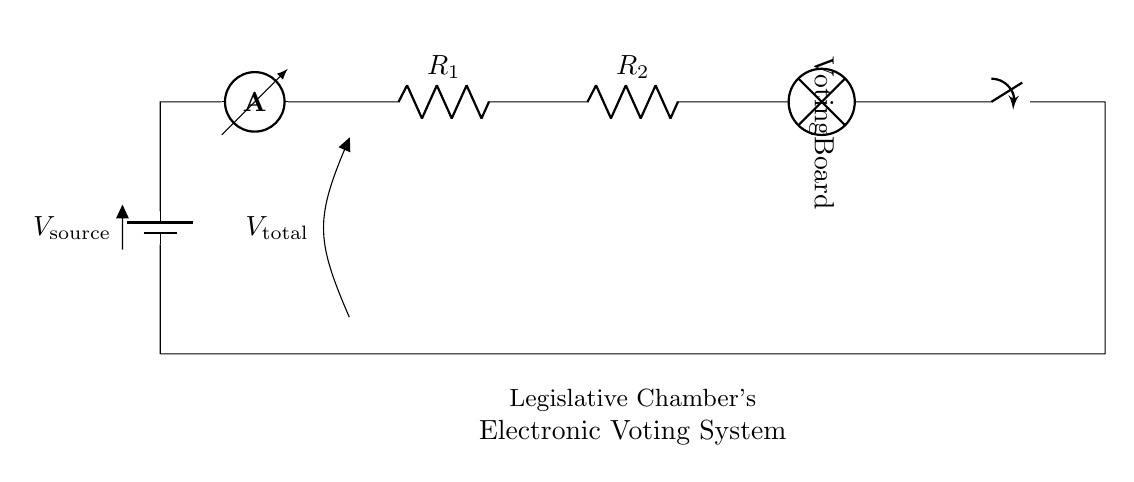What type of circuit is shown? The circuit shown is a series circuit, which features components connected end-to-end, providing a single path for current to flow.
Answer: Series circuit What components are used in the circuit? The components in this circuit diagram are a battery, an ammeter, two resistors, and a lamp (voting board).
Answer: Battery, ammeter, two resistors, lamp What does the ammeter measure in this circuit? The ammeter measures the current flowing through the circuit, which is the same through all components in a series configuration.
Answer: Current What is the function of the voting board in the circuit? The voting board acts as a load that illuminates when current passes through it, indicating that the circuit is complete and functioning.
Answer: Load If the total voltage is 12V, what is the voltage drop across each resistor if they are equal? In a series circuit, the total voltage is divided across the components. With two equal resistors, each would have a voltage drop of 6V (assuming a total of 12V).
Answer: 6V How does the switch affect the circuit when it is open? When the switch is open, it breaks the circuit continuity, stopping current flow and turning off the voting board (lamp).
Answer: Stops current flow What is the significance of using a series circuit in this application? A series circuit ensures that all components receive the same current, which is important for components like the voting board to operate uniformly during voting sessions.
Answer: Uniform operation 